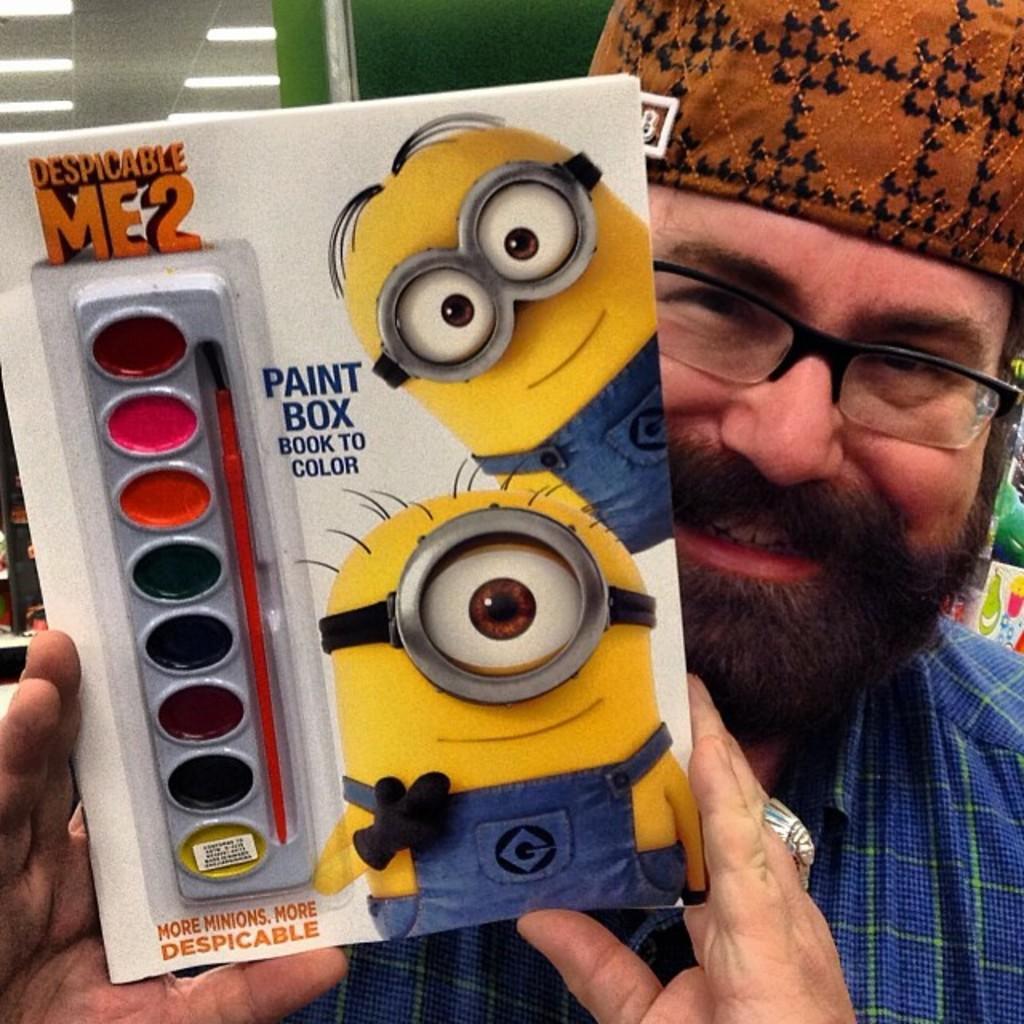How would you summarize this image in a sentence or two? In this picture in the front there is a man standing and smiling and holding a book with some text written on it. In the background there are lights and there is a wall which is green in colour. On the right side there are objects which are green in colour. 